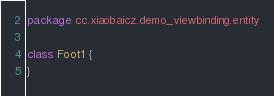Convert code to text. <code><loc_0><loc_0><loc_500><loc_500><_Kotlin_>package cc.xiaobaicz.demo_viewbinding.entity

class Foot1 {
}</code> 